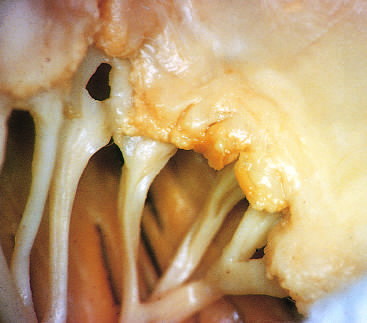what is acute rheumatic mitral valvulitis superimposed on?
Answer the question using a single word or phrase. Chronic rheumatic heart disease 